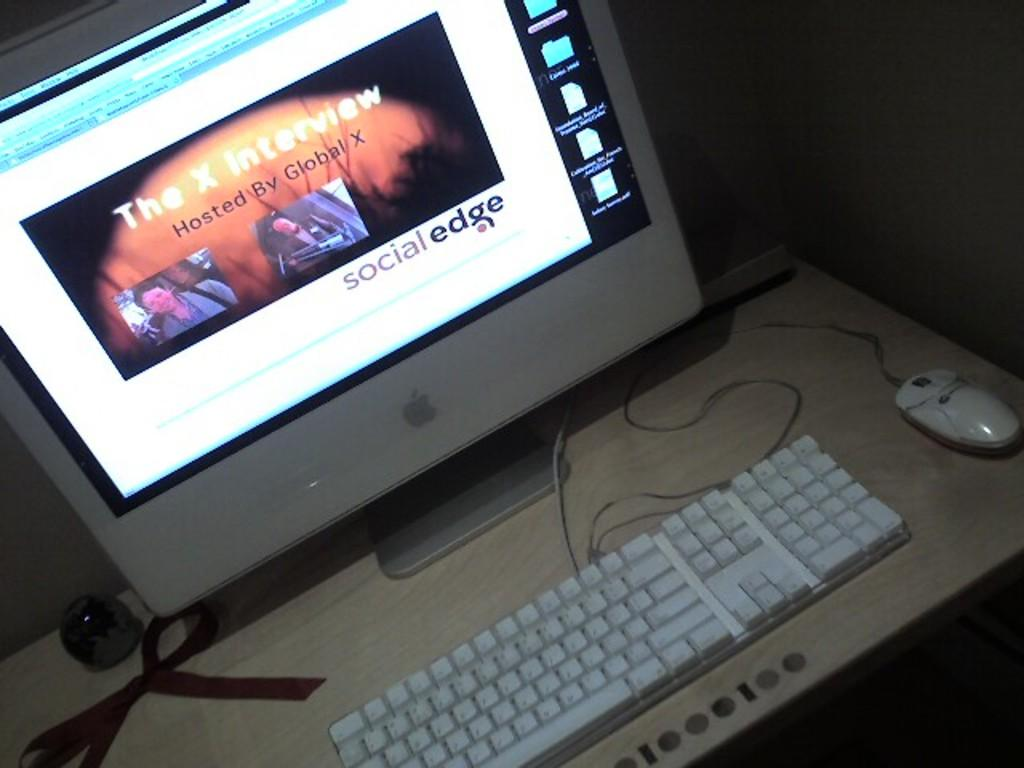<image>
Share a concise interpretation of the image provided. A computer is accessing the internet and at a webpage that reads The X interview. 